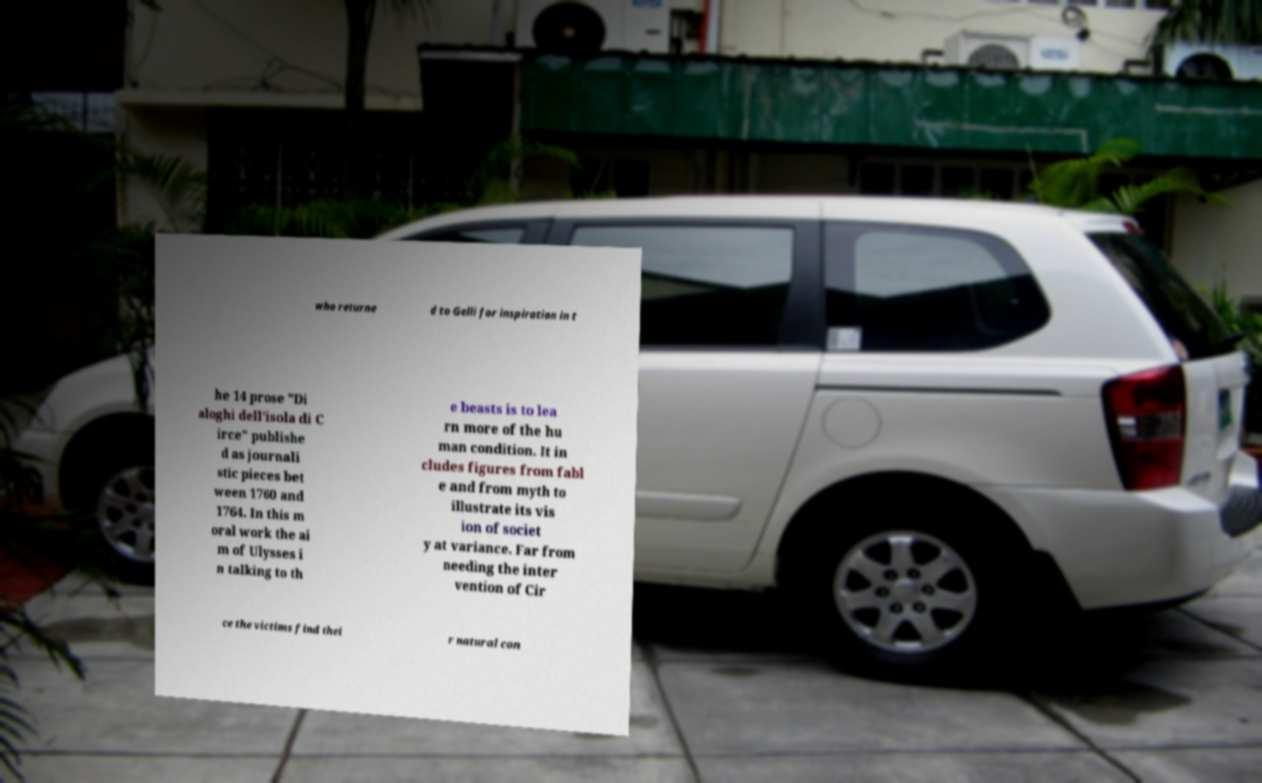For documentation purposes, I need the text within this image transcribed. Could you provide that? who returne d to Gelli for inspiration in t he 14 prose "Di aloghi dell'isola di C irce" publishe d as journali stic pieces bet ween 1760 and 1764. In this m oral work the ai m of Ulysses i n talking to th e beasts is to lea rn more of the hu man condition. It in cludes figures from fabl e and from myth to illustrate its vis ion of societ y at variance. Far from needing the inter vention of Cir ce the victims find thei r natural con 